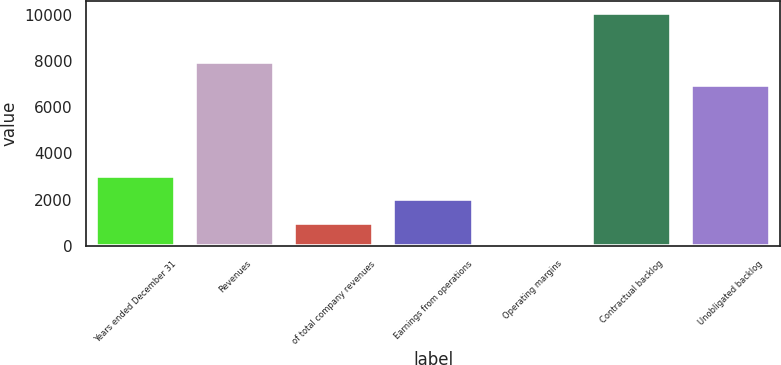<chart> <loc_0><loc_0><loc_500><loc_500><bar_chart><fcel>Years ended December 31<fcel>Revenues<fcel>of total company revenues<fcel>Earnings from operations<fcel>Operating margins<fcel>Contractual backlog<fcel>Unobligated backlog<nl><fcel>3028.37<fcel>7944.09<fcel>1014.19<fcel>2021.28<fcel>7.1<fcel>10078<fcel>6937<nl></chart> 